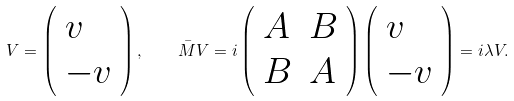Convert formula to latex. <formula><loc_0><loc_0><loc_500><loc_500>V = \left ( \begin{array} { l } { v } \\ { - v } \end{array} \right ) , \quad \bar { M } V = i \left ( \begin{array} { l l } { A } & { B } \\ { B } & { A } \end{array} \right ) \left ( \begin{array} { l } { v } \\ { - v } \end{array} \right ) = i \lambda V .</formula> 